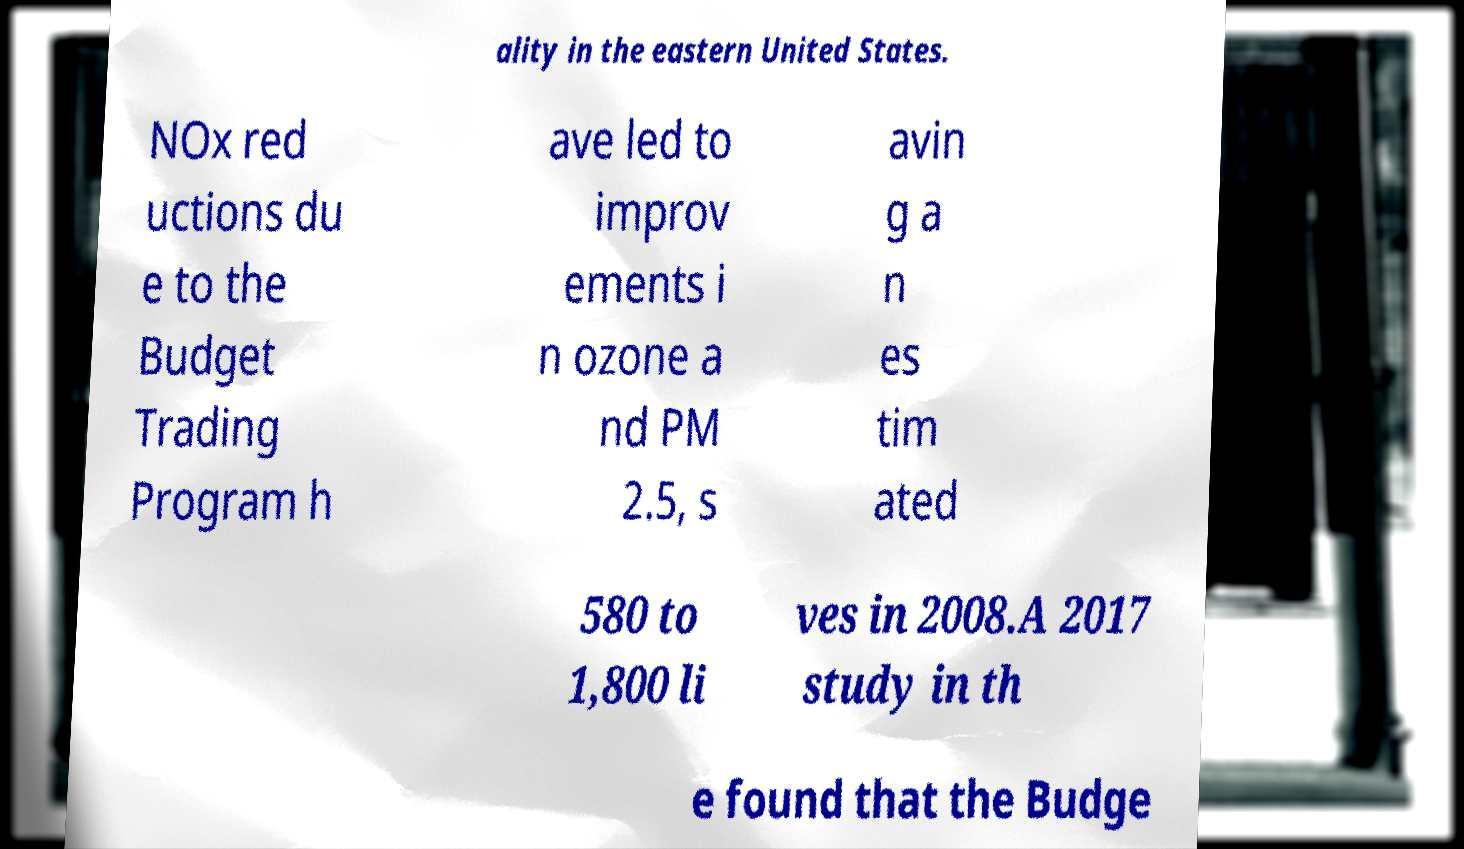Can you accurately transcribe the text from the provided image for me? ality in the eastern United States. NOx red uctions du e to the Budget Trading Program h ave led to improv ements i n ozone a nd PM 2.5, s avin g a n es tim ated 580 to 1,800 li ves in 2008.A 2017 study in th e found that the Budge 